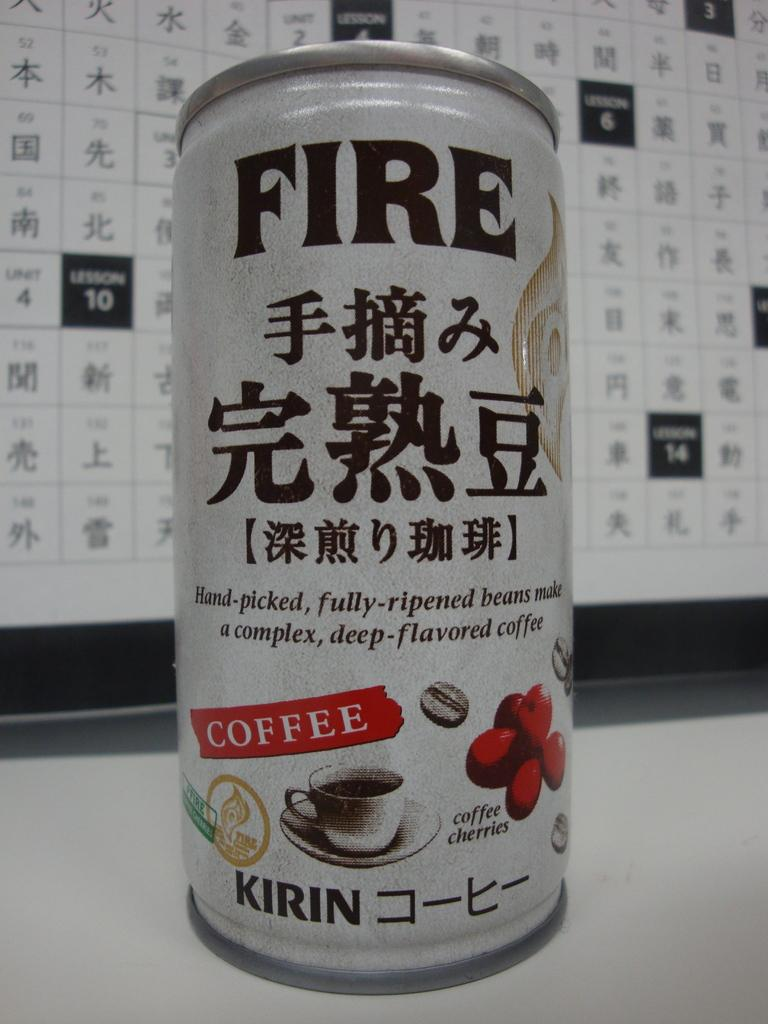Provide a one-sentence caption for the provided image. A can of FIRE coffee sits on a table in front of a lesson planner. 